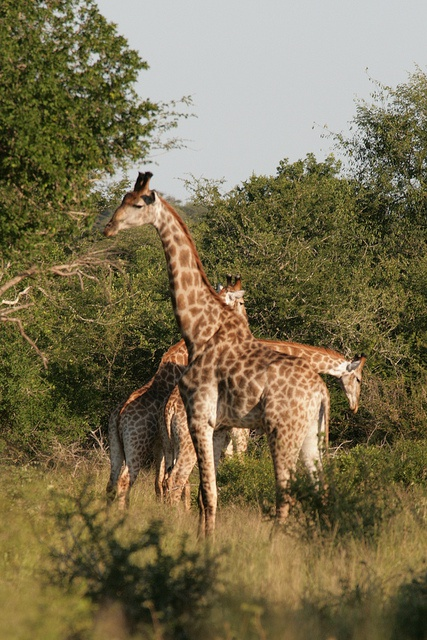Describe the objects in this image and their specific colors. I can see giraffe in darkgreen, gray, maroon, and tan tones, giraffe in darkgreen, black, and gray tones, and giraffe in darkgreen, tan, black, gray, and maroon tones in this image. 